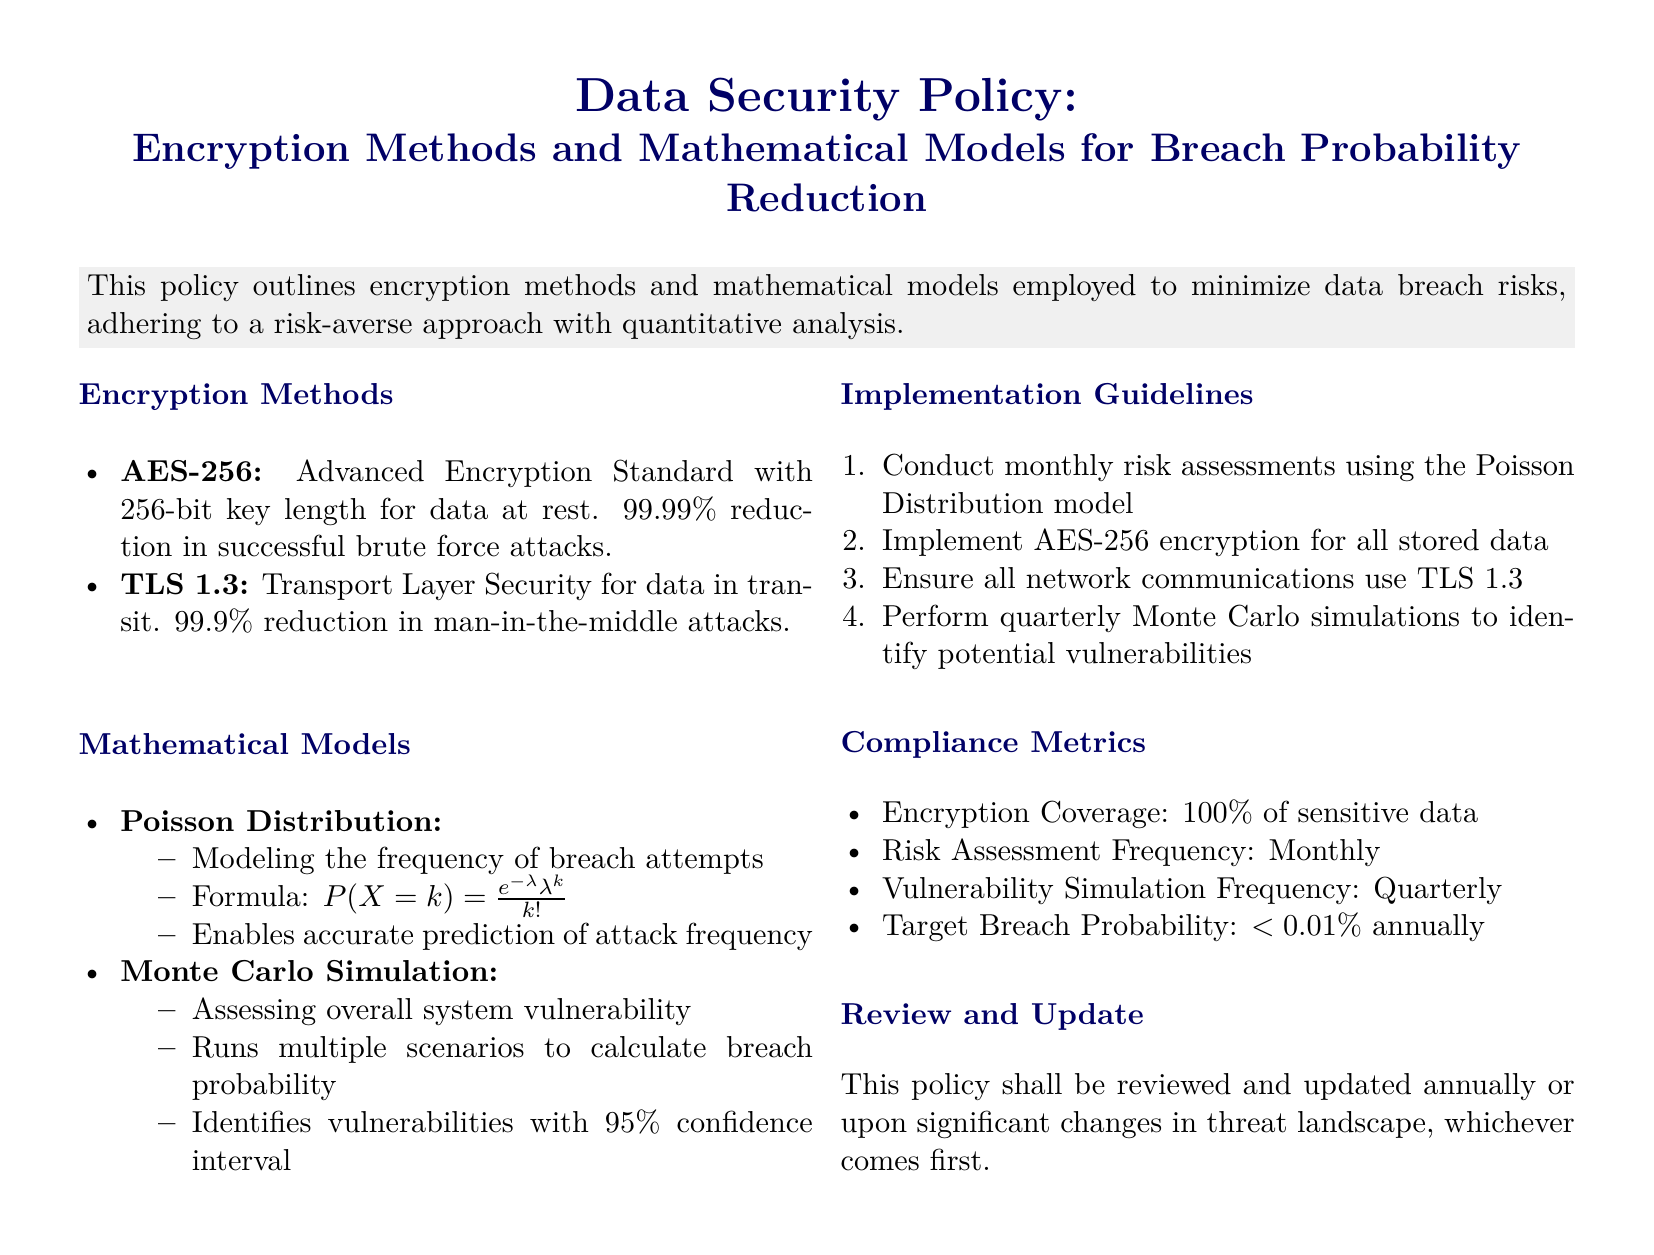What is the encryption method for data at rest? The document specifies that AES-256 is used for data at rest.
Answer: AES-256 What is the reduction percentage for successful brute force attacks? The document states that AES-256 provides a 99.99% reduction in successful brute force attacks.
Answer: 99.99% What is the confidence interval for the Monte Carlo simulation? The document mentions that the Monte Carlo simulation identifies vulnerabilities with a 95% confidence interval.
Answer: 95% How frequently are risk assessments conducted? The document outlines that risk assessments are conducted monthly.
Answer: Monthly What is the target breach probability stated in the policy? The policy sets a target breach probability of less than 0.01% annually.
Answer: <0.01% What type of mathematical model is used to model breach attempts? The document explains that the Poisson Distribution is used to model the frequency of breach attempts.
Answer: Poisson Distribution When will this policy be reviewed? The document specifies that the policy will be reviewed annually or upon significant changes in the threat landscape.
Answer: Annually What encryption method is required for network communications? The document specifies the use of TLS 1.3 for network communications.
Answer: TLS 1.3 What is the frequency of vulnerability simulations? The document states that vulnerability simulations should be performed quarterly.
Answer: Quarterly 